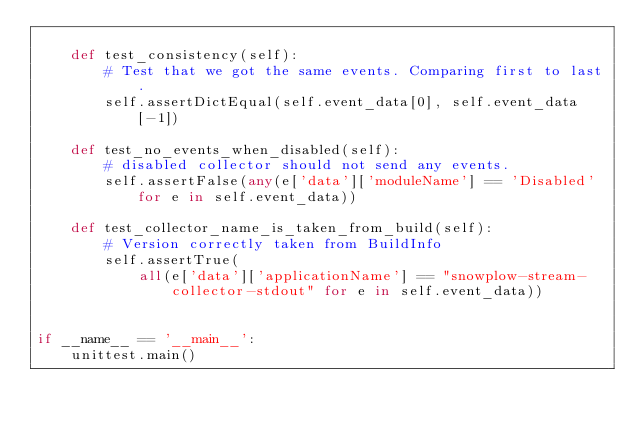<code> <loc_0><loc_0><loc_500><loc_500><_Python_>
    def test_consistency(self):
        # Test that we got the same events. Comparing first to last.
        self.assertDictEqual(self.event_data[0], self.event_data[-1])

    def test_no_events_when_disabled(self):
        # disabled collector should not send any events.
        self.assertFalse(any(e['data']['moduleName'] == 'Disabled' for e in self.event_data))

    def test_collector_name_is_taken_from_build(self):
        # Version correctly taken from BuildInfo
        self.assertTrue(
            all(e['data']['applicationName'] == "snowplow-stream-collector-stdout" for e in self.event_data))


if __name__ == '__main__':
    unittest.main()
</code> 